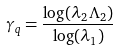Convert formula to latex. <formula><loc_0><loc_0><loc_500><loc_500>\gamma _ { q } = \frac { \log ( \lambda _ { 2 } \Lambda _ { 2 } ) } { \log ( \lambda _ { 1 } ) }</formula> 